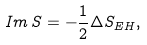<formula> <loc_0><loc_0><loc_500><loc_500>I m \, S = - \frac { 1 } { 2 } \Delta S _ { E H } ,</formula> 